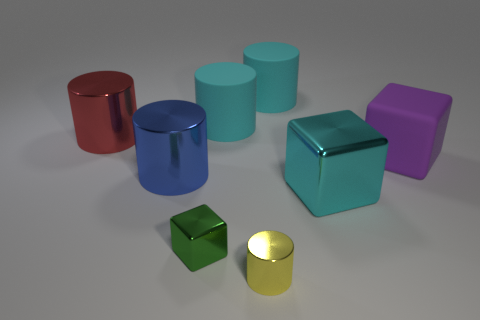What size is the yellow metal thing that is the same shape as the large red shiny object?
Offer a terse response. Small. Are there fewer tiny green things that are left of the blue cylinder than cyan cubes that are in front of the yellow metallic cylinder?
Your answer should be compact. No. What is the shape of the object that is to the right of the yellow object and behind the red metallic object?
Offer a very short reply. Cylinder. There is a yellow cylinder that is made of the same material as the blue cylinder; what is its size?
Ensure brevity in your answer.  Small. Is the color of the big shiny block the same as the matte object that is left of the small metal cylinder?
Your answer should be compact. Yes. What is the material of the cylinder that is both left of the yellow metal cylinder and to the right of the blue cylinder?
Keep it short and to the point. Rubber. There is a cyan thing that is in front of the big purple object; is its shape the same as the large metallic object that is behind the purple thing?
Offer a terse response. No. Are any yellow rubber cylinders visible?
Ensure brevity in your answer.  No. There is another matte object that is the same shape as the small green thing; what color is it?
Offer a terse response. Purple. The metallic block that is the same size as the purple rubber block is what color?
Your response must be concise. Cyan. 